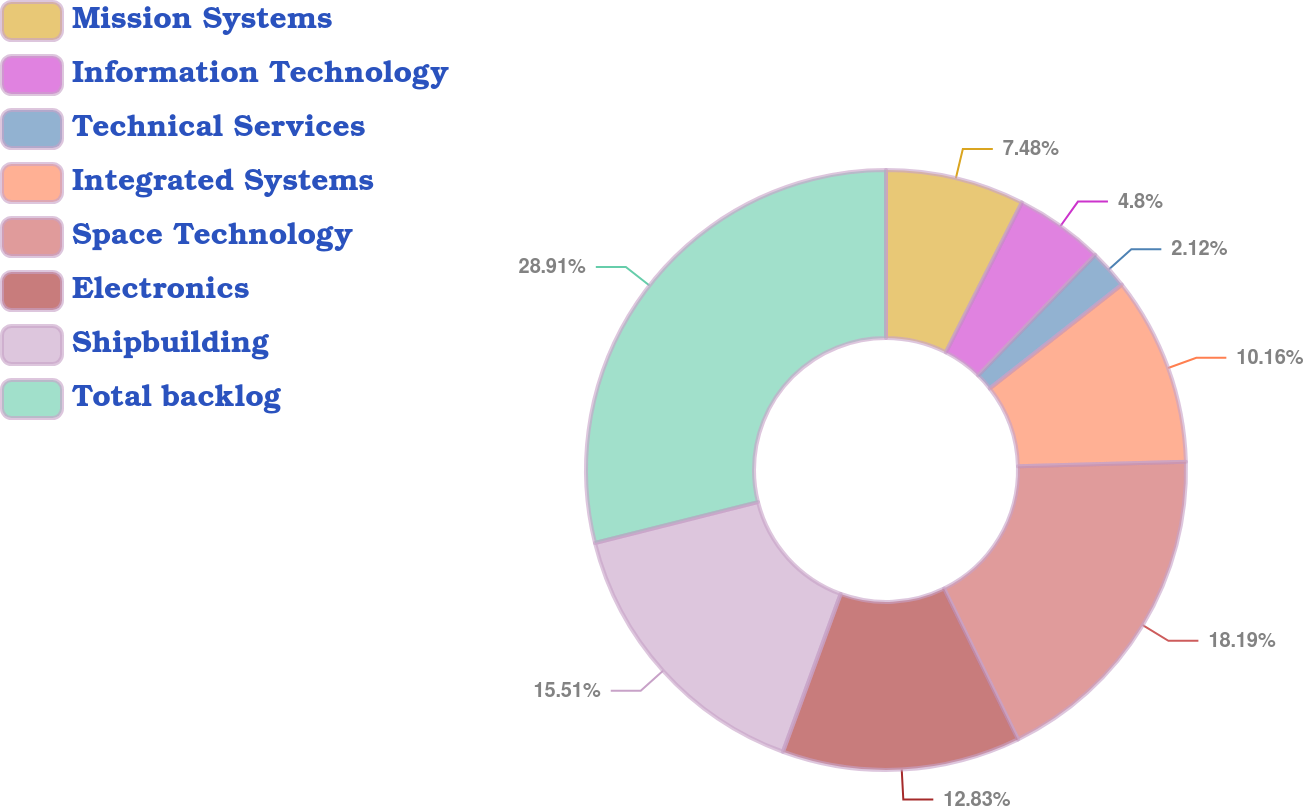Convert chart to OTSL. <chart><loc_0><loc_0><loc_500><loc_500><pie_chart><fcel>Mission Systems<fcel>Information Technology<fcel>Technical Services<fcel>Integrated Systems<fcel>Space Technology<fcel>Electronics<fcel>Shipbuilding<fcel>Total backlog<nl><fcel>7.48%<fcel>4.8%<fcel>2.12%<fcel>10.16%<fcel>18.19%<fcel>12.83%<fcel>15.51%<fcel>28.91%<nl></chart> 